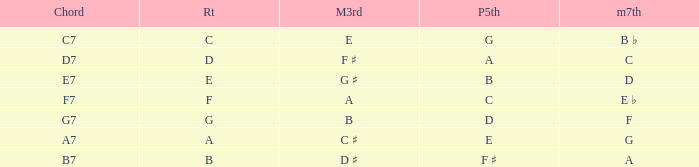What is the Major third with a Perfect fifth that is d? B. Could you parse the entire table as a dict? {'header': ['Chord', 'Rt', 'M3rd', 'P5th', 'm7th'], 'rows': [['C7', 'C', 'E', 'G', 'B ♭'], ['D7', 'D', 'F ♯', 'A', 'C'], ['E7', 'E', 'G ♯', 'B', 'D'], ['F7', 'F', 'A', 'C', 'E ♭'], ['G7', 'G', 'B', 'D', 'F'], ['A7', 'A', 'C ♯', 'E', 'G'], ['B7', 'B', 'D ♯', 'F ♯', 'A']]} 